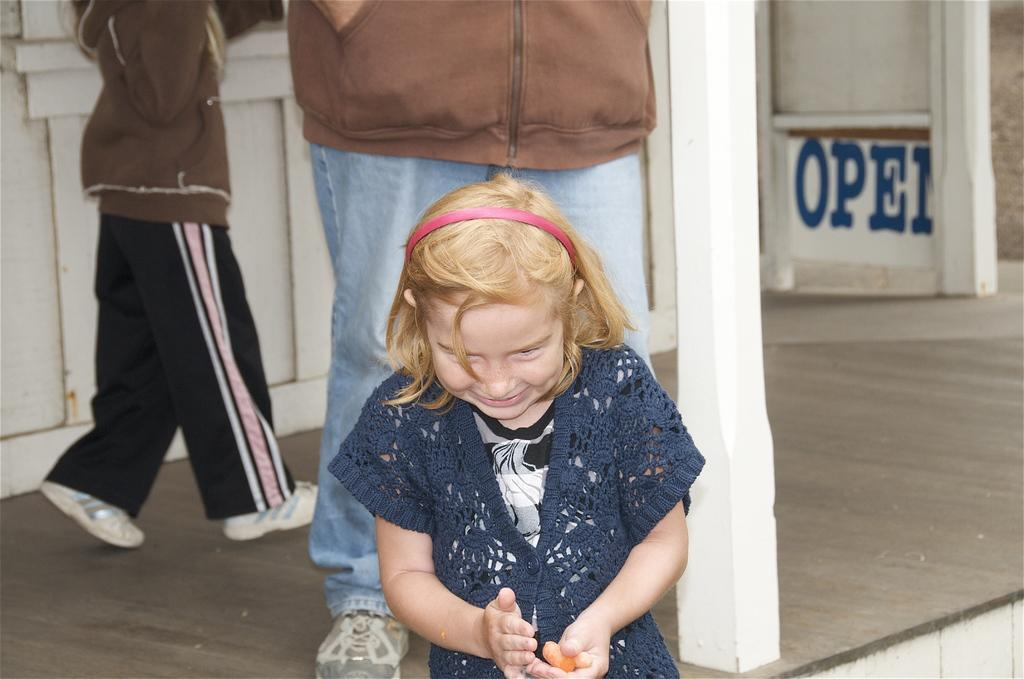What is the main subject of the picture? The main subject of the picture is a girl child. Where is the girl sitting in the picture? The girl is sitting near a white pillar. Can you describe the person behind the girl? There is a person standing behind the girl. What is happening in the background of the picture? Some people are walking near a wall in the background. What type of shock can be seen affecting the turkey in the image? There is no turkey present in the image, and therefore no shock can be observed. How does the growth of the girl child compare to the growth of the white pillar in the image? The image does not provide any information about the growth of the girl child or the white pillar, so it cannot be compared. 